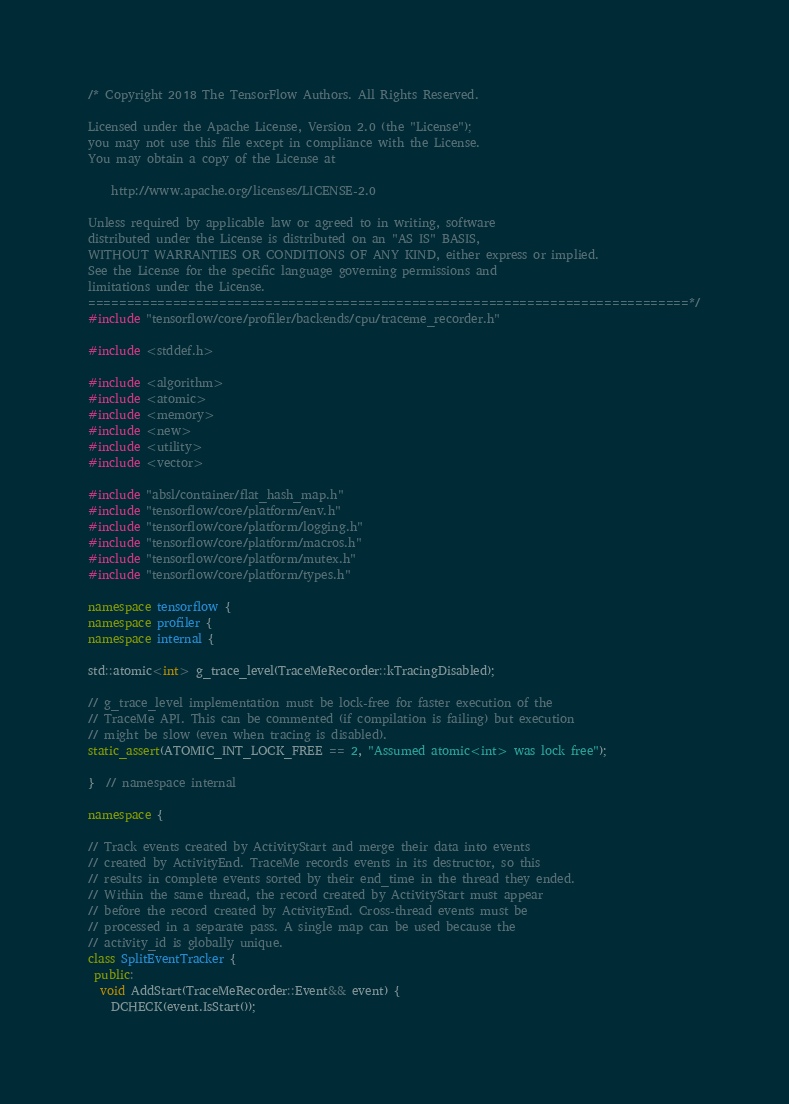<code> <loc_0><loc_0><loc_500><loc_500><_C++_>/* Copyright 2018 The TensorFlow Authors. All Rights Reserved.

Licensed under the Apache License, Version 2.0 (the "License");
you may not use this file except in compliance with the License.
You may obtain a copy of the License at

    http://www.apache.org/licenses/LICENSE-2.0

Unless required by applicable law or agreed to in writing, software
distributed under the License is distributed on an "AS IS" BASIS,
WITHOUT WARRANTIES OR CONDITIONS OF ANY KIND, either express or implied.
See the License for the specific language governing permissions and
limitations under the License.
==============================================================================*/
#include "tensorflow/core/profiler/backends/cpu/traceme_recorder.h"

#include <stddef.h>

#include <algorithm>
#include <atomic>
#include <memory>
#include <new>
#include <utility>
#include <vector>

#include "absl/container/flat_hash_map.h"
#include "tensorflow/core/platform/env.h"
#include "tensorflow/core/platform/logging.h"
#include "tensorflow/core/platform/macros.h"
#include "tensorflow/core/platform/mutex.h"
#include "tensorflow/core/platform/types.h"

namespace tensorflow {
namespace profiler {
namespace internal {

std::atomic<int> g_trace_level(TraceMeRecorder::kTracingDisabled);

// g_trace_level implementation must be lock-free for faster execution of the
// TraceMe API. This can be commented (if compilation is failing) but execution
// might be slow (even when tracing is disabled).
static_assert(ATOMIC_INT_LOCK_FREE == 2, "Assumed atomic<int> was lock free");

}  // namespace internal

namespace {

// Track events created by ActivityStart and merge their data into events
// created by ActivityEnd. TraceMe records events in its destructor, so this
// results in complete events sorted by their end_time in the thread they ended.
// Within the same thread, the record created by ActivityStart must appear
// before the record created by ActivityEnd. Cross-thread events must be
// processed in a separate pass. A single map can be used because the
// activity_id is globally unique.
class SplitEventTracker {
 public:
  void AddStart(TraceMeRecorder::Event&& event) {
    DCHECK(event.IsStart());</code> 